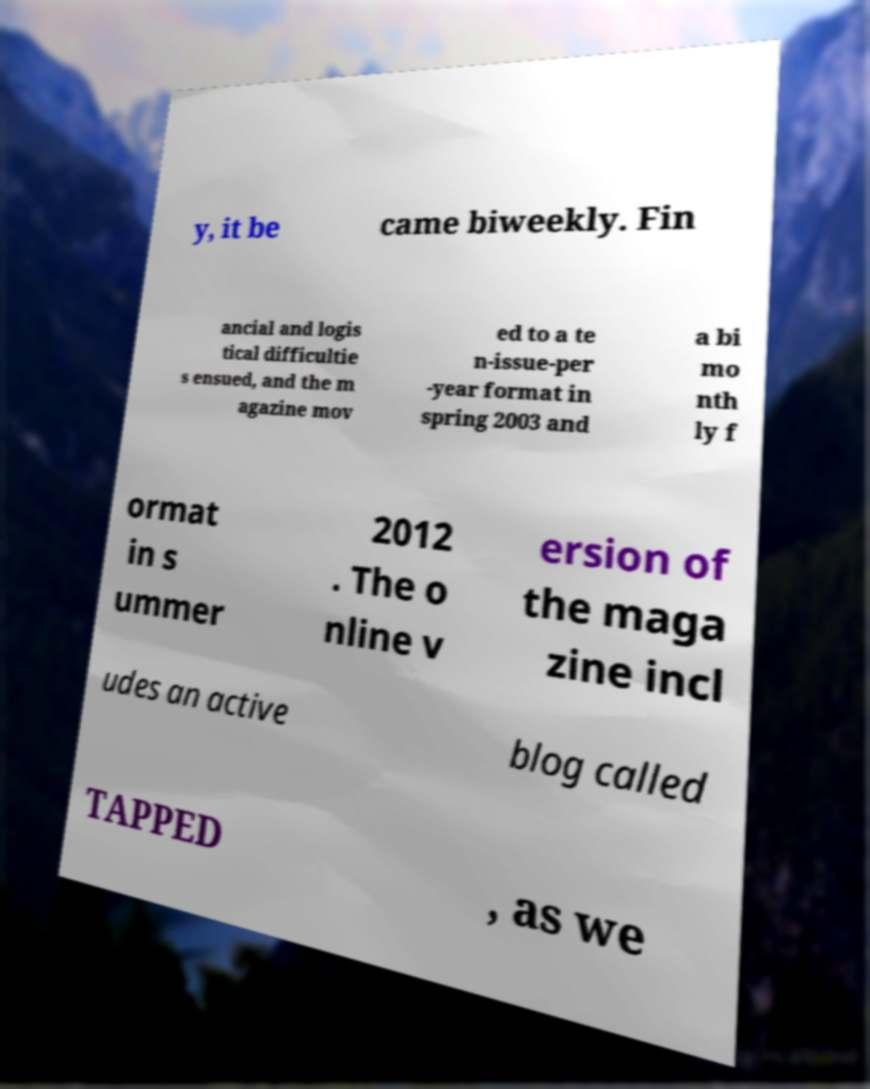Could you assist in decoding the text presented in this image and type it out clearly? y, it be came biweekly. Fin ancial and logis tical difficultie s ensued, and the m agazine mov ed to a te n-issue-per -year format in spring 2003 and a bi mo nth ly f ormat in s ummer 2012 . The o nline v ersion of the maga zine incl udes an active blog called TAPPED , as we 